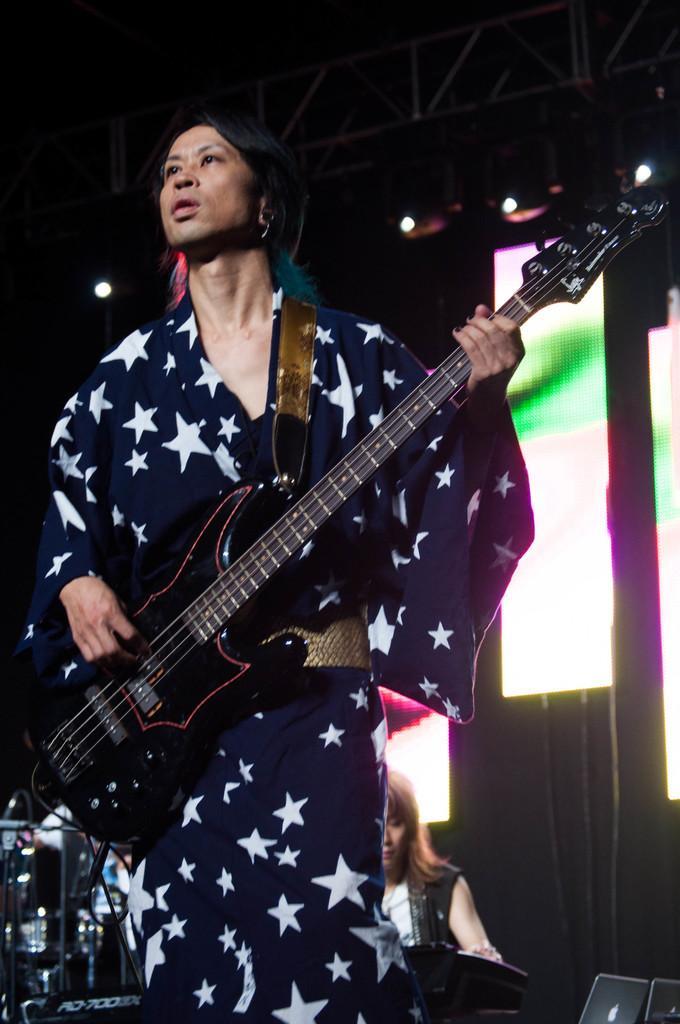How would you summarize this image in a sentence or two? In front of the picture, we see a man is standing and he is holding the guitar. He is playing the guitar. In the left bottom, we see the musical instruments. Behind him, we see a girl is playing the musical instrument. In the right bottom, we see the laptops. In the background, we see a board in green and yellow color. At the top, we see the lights. In the background, it is black in color. This picture is clicked in the dark. 